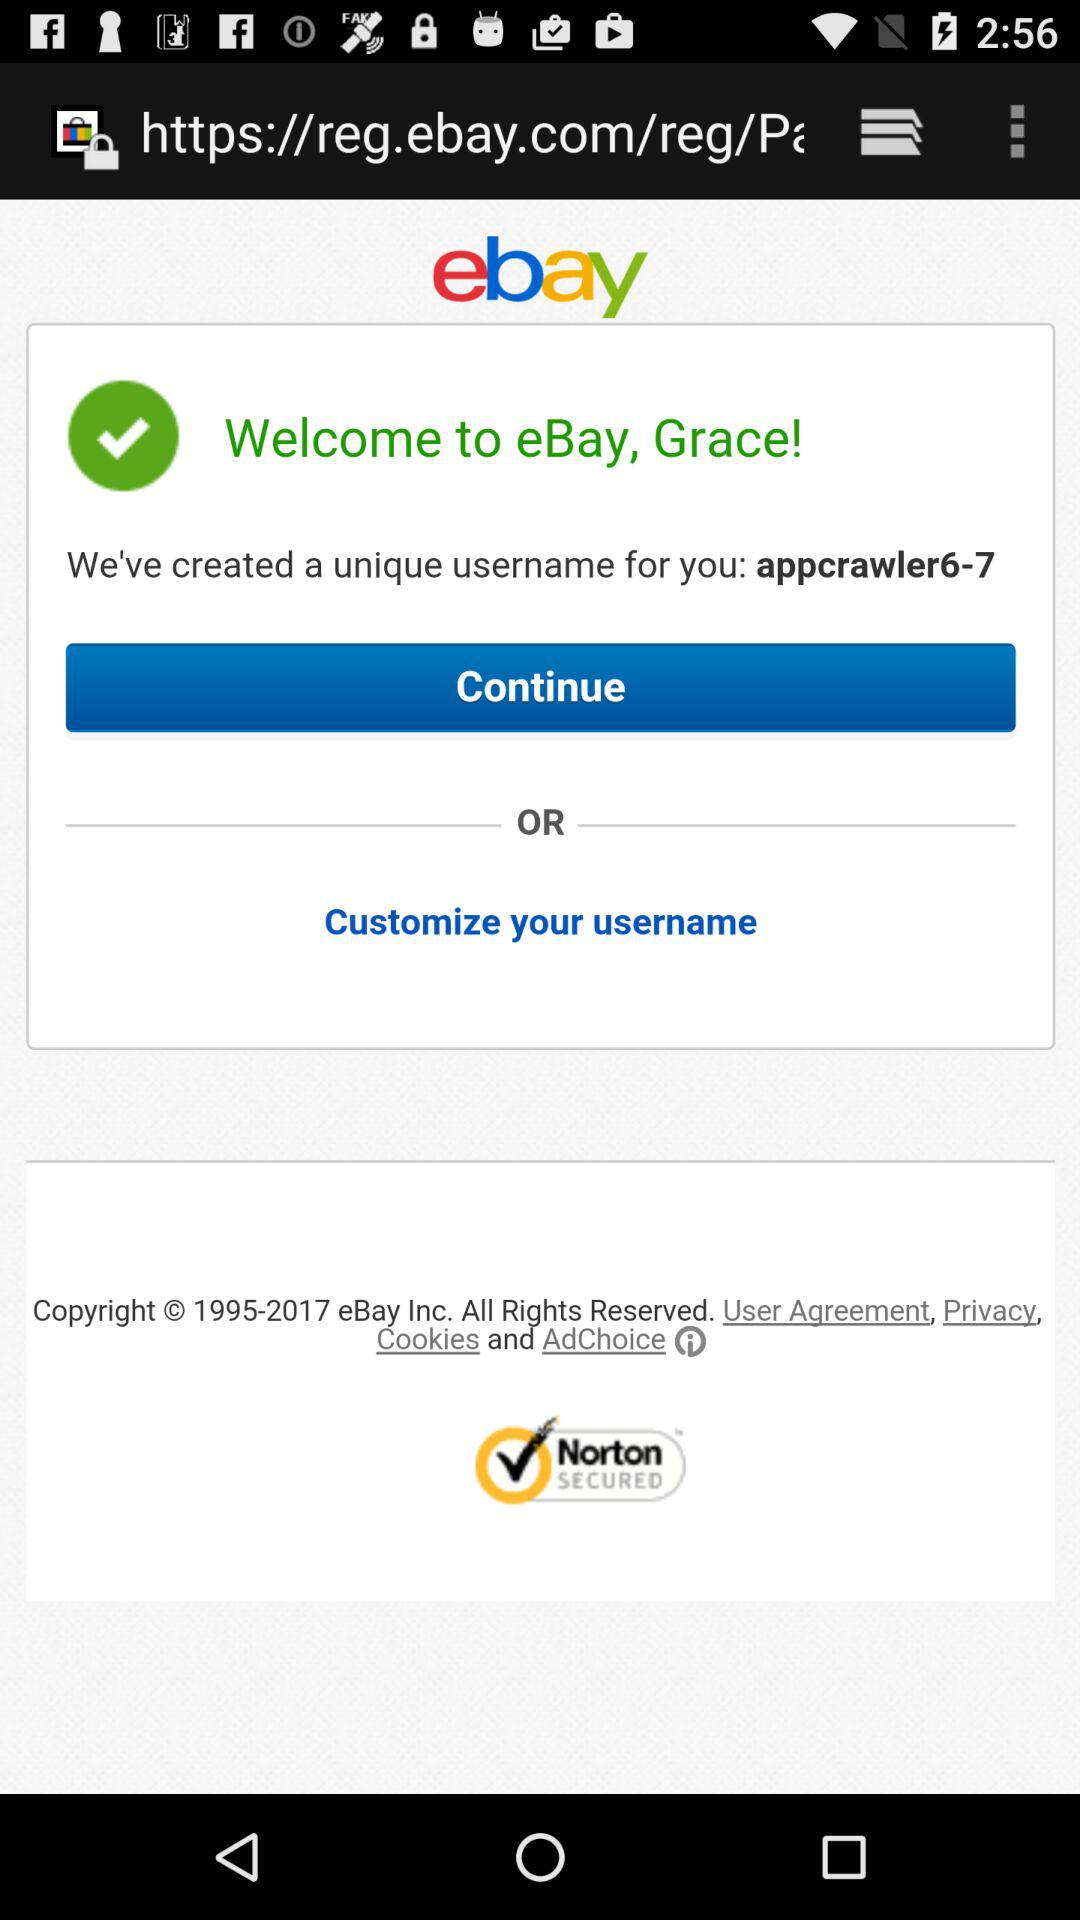What is the name of the user? The name of the user is Grace. 